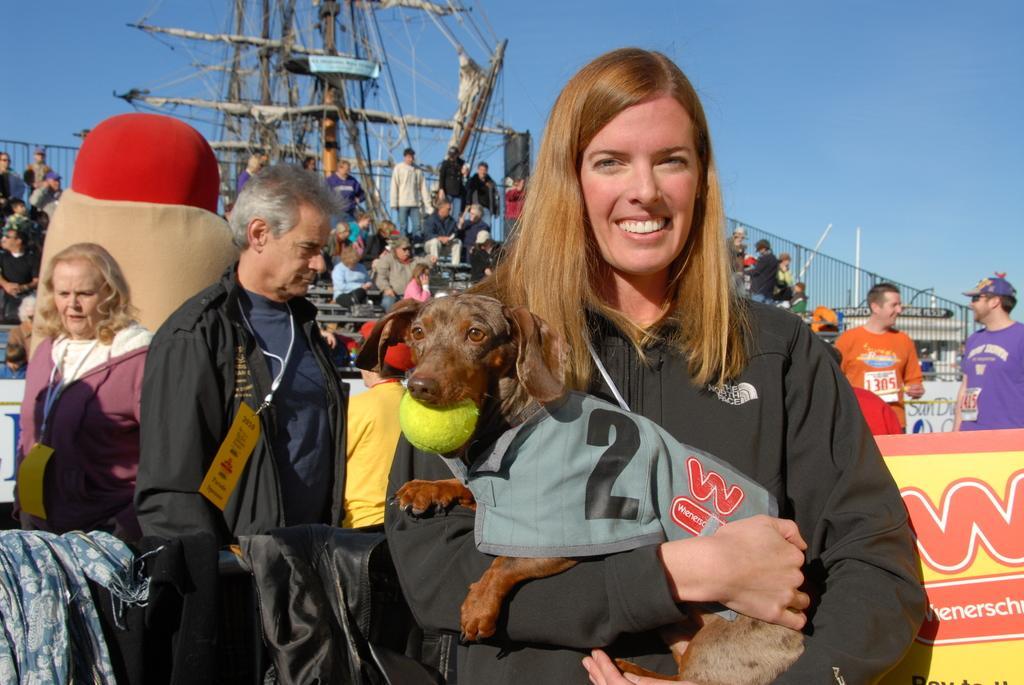Could you give a brief overview of what you see in this image? This picture shows a group of people standing and we see a woman holding a dog in her hands and we see a ball in dogs mouth and we see a blue cloudy sky. 